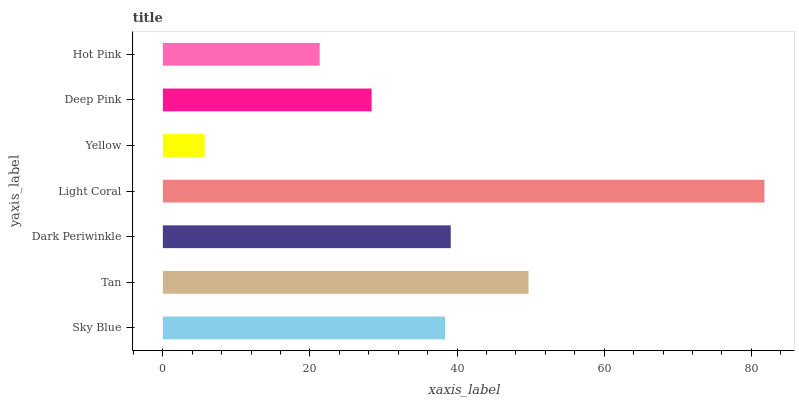Is Yellow the minimum?
Answer yes or no. Yes. Is Light Coral the maximum?
Answer yes or no. Yes. Is Tan the minimum?
Answer yes or no. No. Is Tan the maximum?
Answer yes or no. No. Is Tan greater than Sky Blue?
Answer yes or no. Yes. Is Sky Blue less than Tan?
Answer yes or no. Yes. Is Sky Blue greater than Tan?
Answer yes or no. No. Is Tan less than Sky Blue?
Answer yes or no. No. Is Sky Blue the high median?
Answer yes or no. Yes. Is Sky Blue the low median?
Answer yes or no. Yes. Is Deep Pink the high median?
Answer yes or no. No. Is Hot Pink the low median?
Answer yes or no. No. 